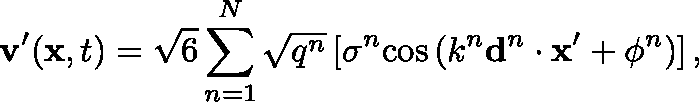<formula> <loc_0><loc_0><loc_500><loc_500>v ^ { \prime } ( x , t ) = \sqrt { 6 } \sum _ { n = 1 } ^ { N } \sqrt { q ^ { n } } \left [ \sigma ^ { n } \cos \left ( k ^ { n } d ^ { n } \cdot x ^ { \prime } + \phi ^ { n } \right ) \right ] ,</formula> 